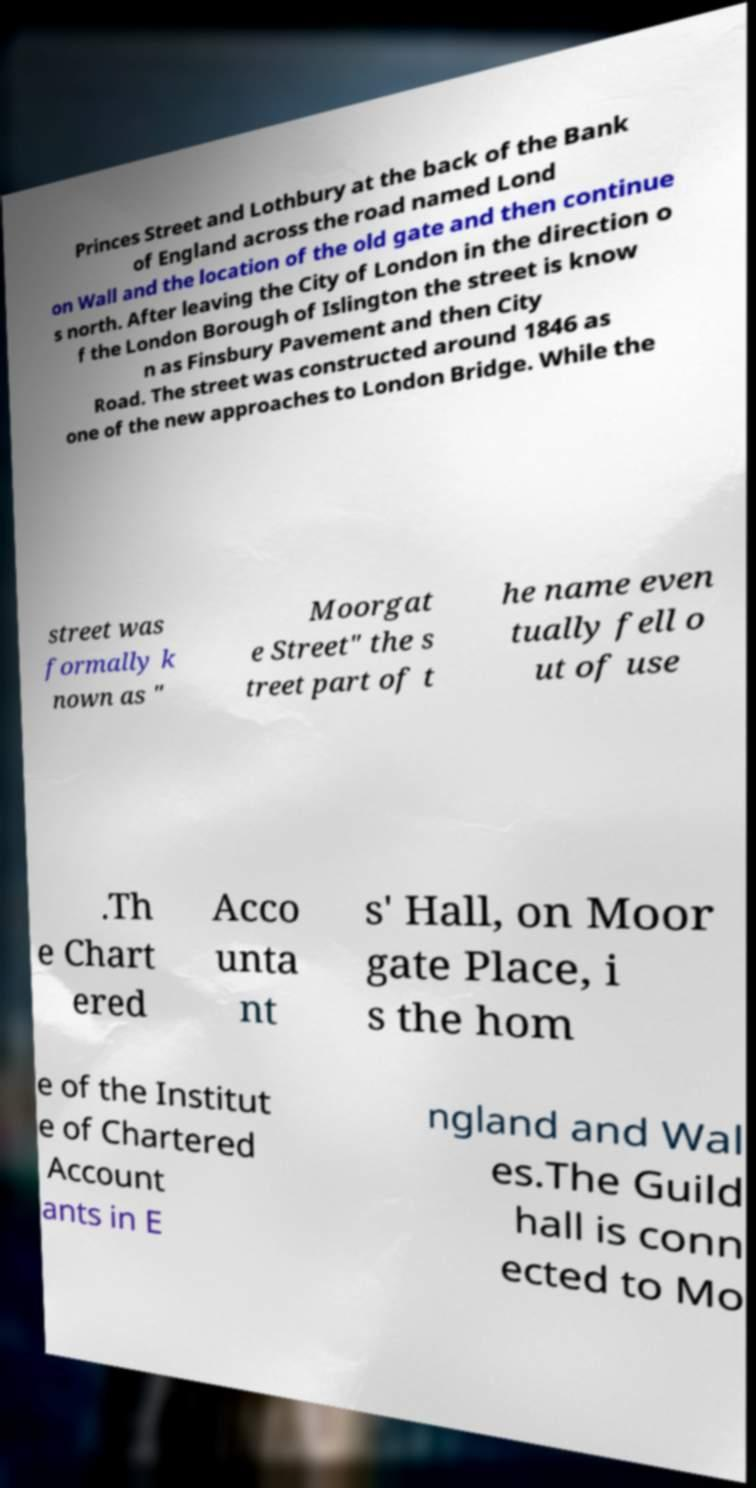I need the written content from this picture converted into text. Can you do that? Princes Street and Lothbury at the back of the Bank of England across the road named Lond on Wall and the location of the old gate and then continue s north. After leaving the City of London in the direction o f the London Borough of Islington the street is know n as Finsbury Pavement and then City Road. The street was constructed around 1846 as one of the new approaches to London Bridge. While the street was formally k nown as " Moorgat e Street" the s treet part of t he name even tually fell o ut of use .Th e Chart ered Acco unta nt s' Hall, on Moor gate Place, i s the hom e of the Institut e of Chartered Account ants in E ngland and Wal es.The Guild hall is conn ected to Mo 